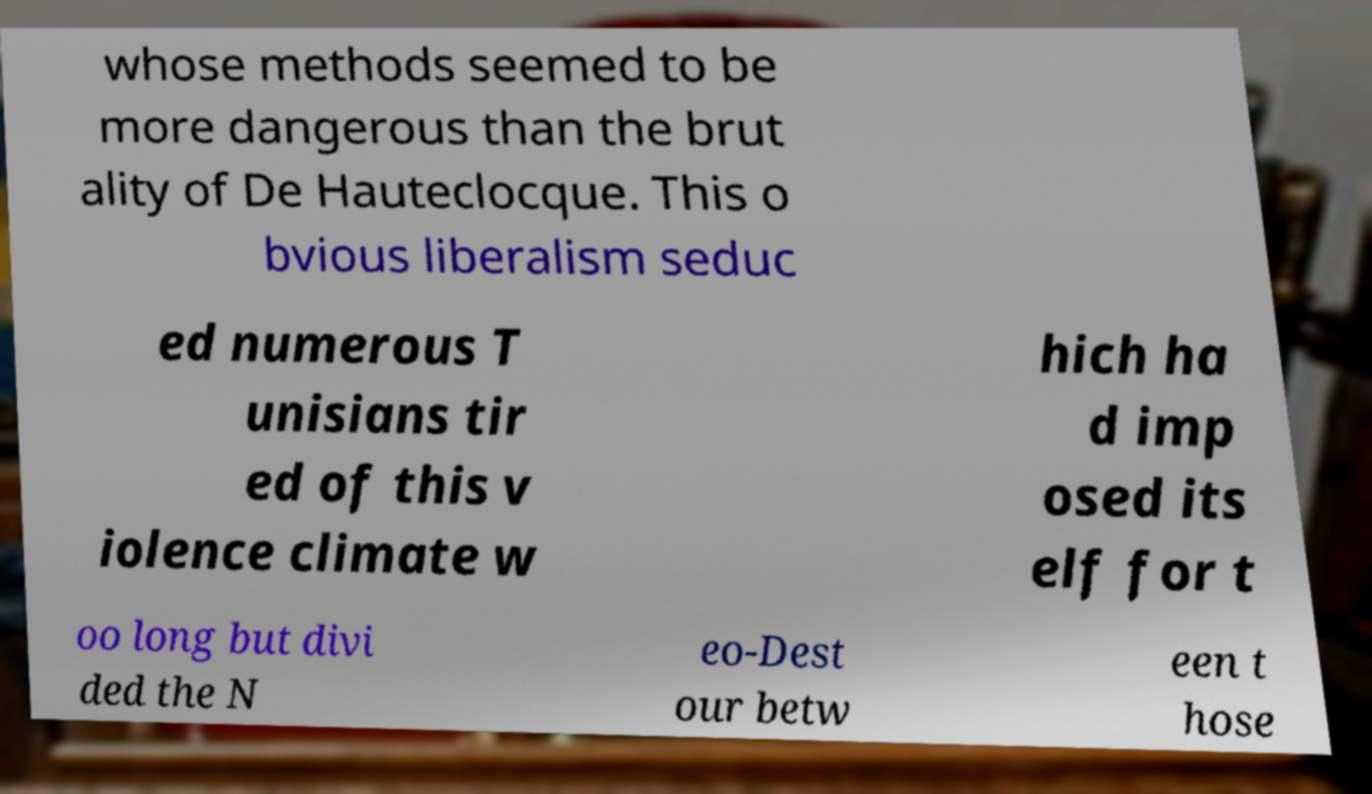Please identify and transcribe the text found in this image. whose methods seemed to be more dangerous than the brut ality of De Hauteclocque. This o bvious liberalism seduc ed numerous T unisians tir ed of this v iolence climate w hich ha d imp osed its elf for t oo long but divi ded the N eo-Dest our betw een t hose 